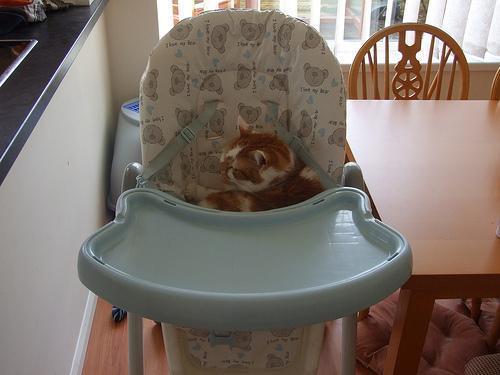How many stuffed animals in the high chair?
Give a very brief answer. 1. 